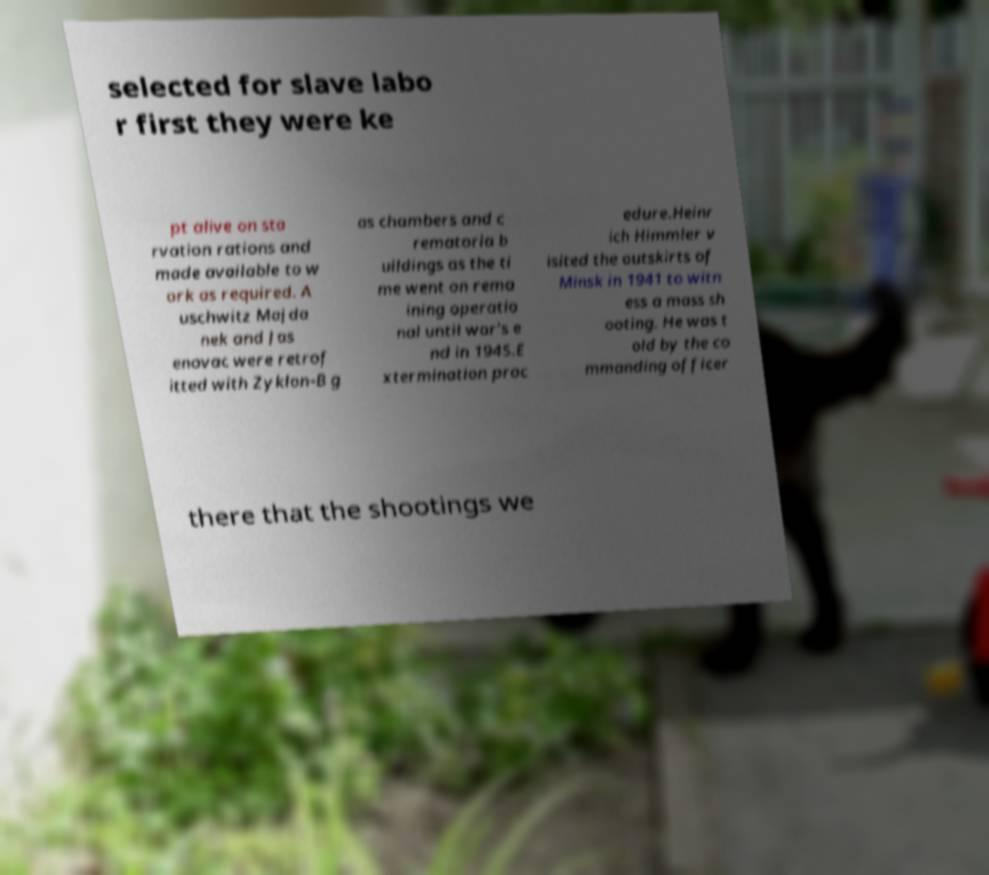Can you read and provide the text displayed in the image?This photo seems to have some interesting text. Can you extract and type it out for me? selected for slave labo r first they were ke pt alive on sta rvation rations and made available to w ork as required. A uschwitz Majda nek and Jas enovac were retrof itted with Zyklon-B g as chambers and c rematoria b uildings as the ti me went on rema ining operatio nal until war's e nd in 1945.E xtermination proc edure.Heinr ich Himmler v isited the outskirts of Minsk in 1941 to witn ess a mass sh ooting. He was t old by the co mmanding officer there that the shootings we 